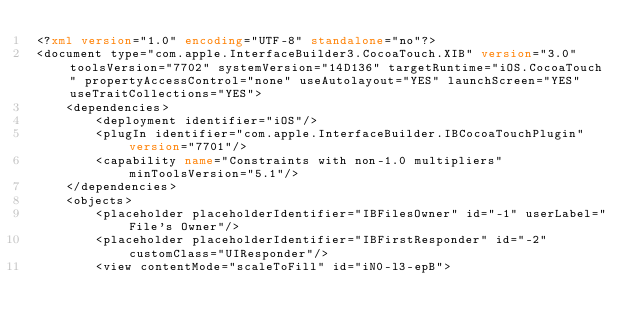<code> <loc_0><loc_0><loc_500><loc_500><_XML_><?xml version="1.0" encoding="UTF-8" standalone="no"?>
<document type="com.apple.InterfaceBuilder3.CocoaTouch.XIB" version="3.0" toolsVersion="7702" systemVersion="14D136" targetRuntime="iOS.CocoaTouch" propertyAccessControl="none" useAutolayout="YES" launchScreen="YES" useTraitCollections="YES">
    <dependencies>
        <deployment identifier="iOS"/>
        <plugIn identifier="com.apple.InterfaceBuilder.IBCocoaTouchPlugin" version="7701"/>
        <capability name="Constraints with non-1.0 multipliers" minToolsVersion="5.1"/>
    </dependencies>
    <objects>
        <placeholder placeholderIdentifier="IBFilesOwner" id="-1" userLabel="File's Owner"/>
        <placeholder placeholderIdentifier="IBFirstResponder" id="-2" customClass="UIResponder"/>
        <view contentMode="scaleToFill" id="iN0-l3-epB"></code> 